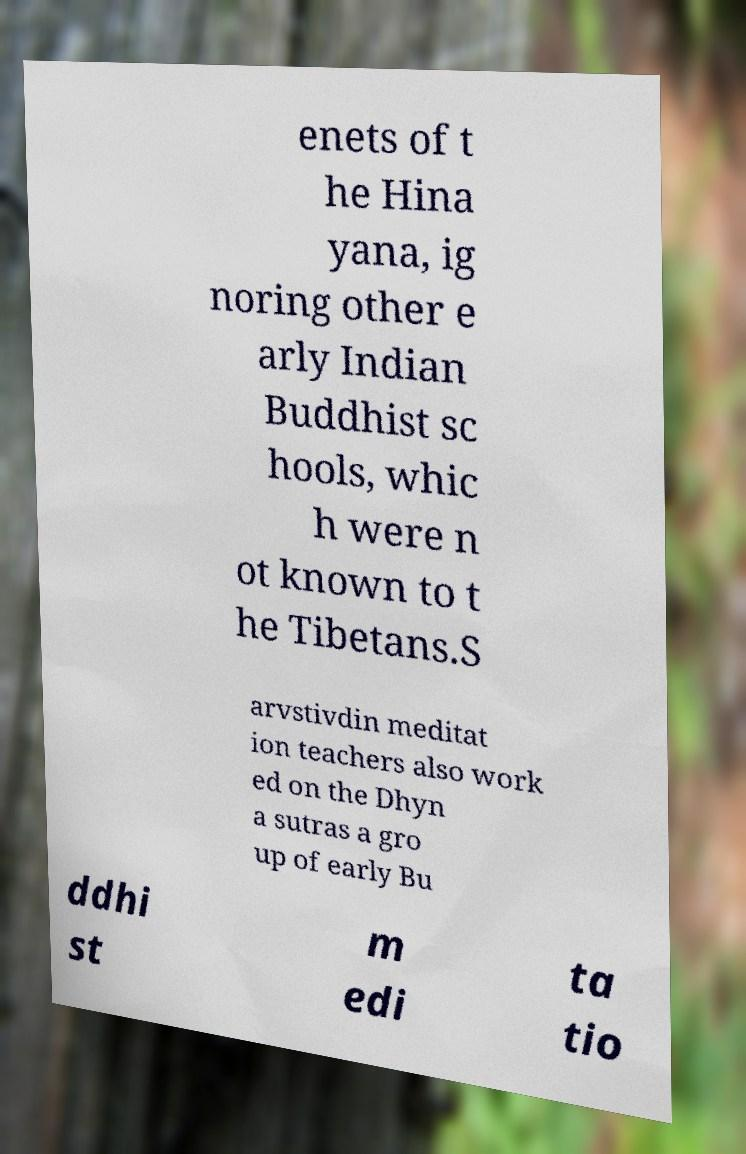Could you extract and type out the text from this image? enets of t he Hina yana, ig noring other e arly Indian Buddhist sc hools, whic h were n ot known to t he Tibetans.S arvstivdin meditat ion teachers also work ed on the Dhyn a sutras a gro up of early Bu ddhi st m edi ta tio 